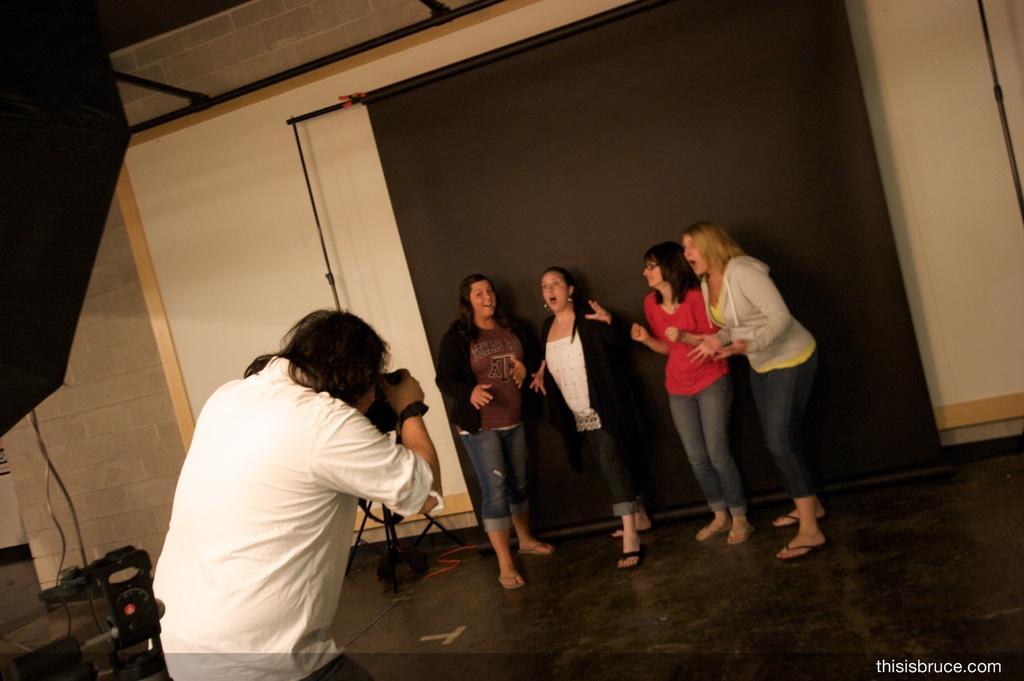How would you summarize this image in a sentence or two? In this image, we can see people standing and in the background, we can see a curtain, stand, screen, umbrella, cables and some objects and there is a wall. In the front, we can see a person holding camera. At the bottom, there is floor and we can see some text. 